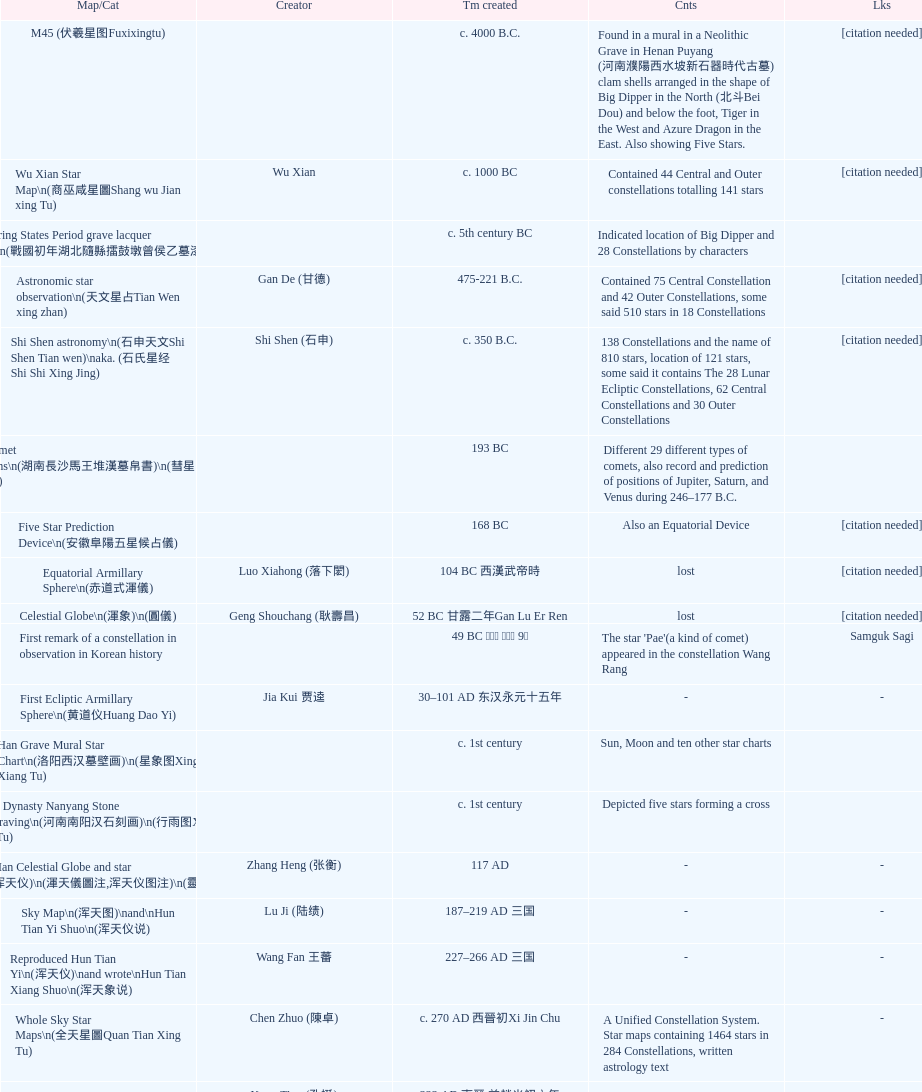Which chinese star map was the first one to be made? M45 (伏羲星图Fuxixingtu). 